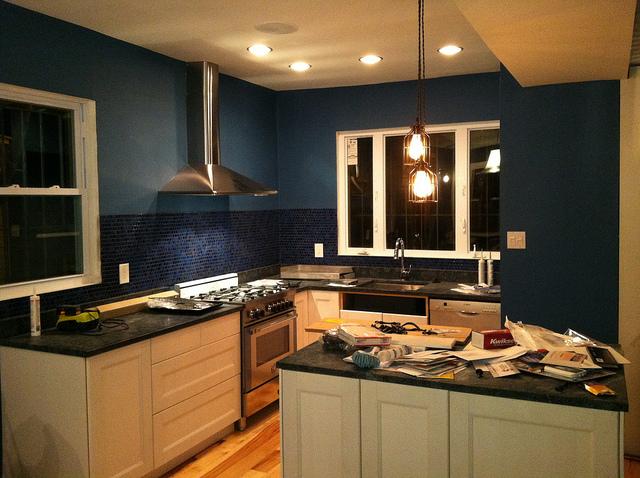What room is this?
Be succinct. Kitchen. Is anything missing from the doors and drawers?
Concise answer only. Handles. Is the counter cluttered or neat?
Write a very short answer. Cluttered. 